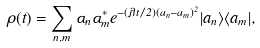Convert formula to latex. <formula><loc_0><loc_0><loc_500><loc_500>\rho ( t ) = \sum _ { n , m } \alpha _ { n } \alpha ^ { * } _ { m } e ^ { - ( \lambda t / 2 ) ( a _ { n } - a _ { m } ) ^ { 2 } } | a _ { n } \rangle \langle a _ { m } | ,</formula> 